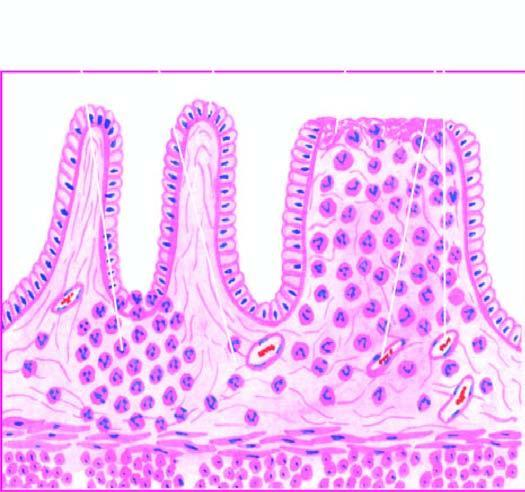what are microscopic features seen superficial ulcerations with?
Answer the question using a single word or phrase. Mucosal infiltration 